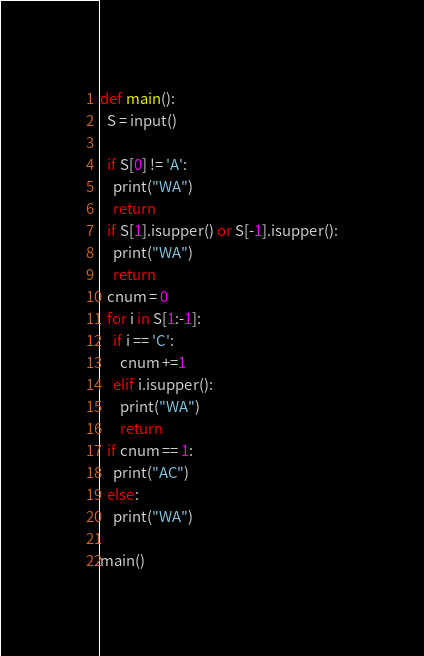Convert code to text. <code><loc_0><loc_0><loc_500><loc_500><_Python_>def main():
  S = input()
  
  if S[0] != 'A':
    print("WA")
    return
  if S[1].isupper() or S[-1].isupper():
    print("WA")
    return
  cnum = 0
  for i in S[1:-1]:
    if i == 'C':
      cnum +=1
    elif i.isupper():
      print("WA")
      return
  if cnum == 1:
    print("AC")
  else:
    print("WA")

main()</code> 